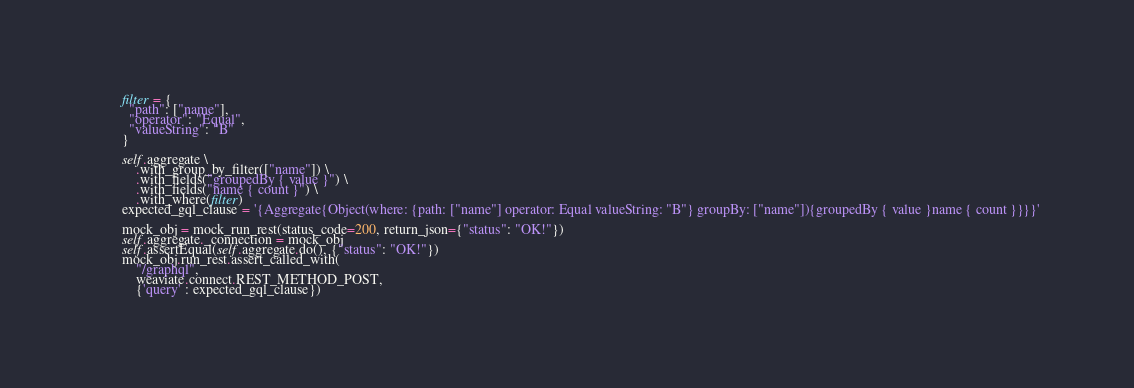Convert code to text. <code><loc_0><loc_0><loc_500><loc_500><_Python_>
        filter = {
          "path": ["name"],
          "operator": "Equal",
          "valueString": "B"
        }

        self.aggregate \
            .with_group_by_filter(["name"]) \
            .with_fields("groupedBy { value }") \
            .with_fields("name { count }") \
            .with_where(filter)
        expected_gql_clause = '{Aggregate{Object(where: {path: ["name"] operator: Equal valueString: "B"} groupBy: ["name"]){groupedBy { value }name { count }}}}'

        mock_obj = mock_run_rest(status_code=200, return_json={"status": "OK!"})
        self.aggregate._connection = mock_obj
        self.assertEqual(self.aggregate.do(), {"status": "OK!"})
        mock_obj.run_rest.assert_called_with(
            "/graphql",
            weaviate.connect.REST_METHOD_POST,
            {'query' : expected_gql_clause})
</code> 